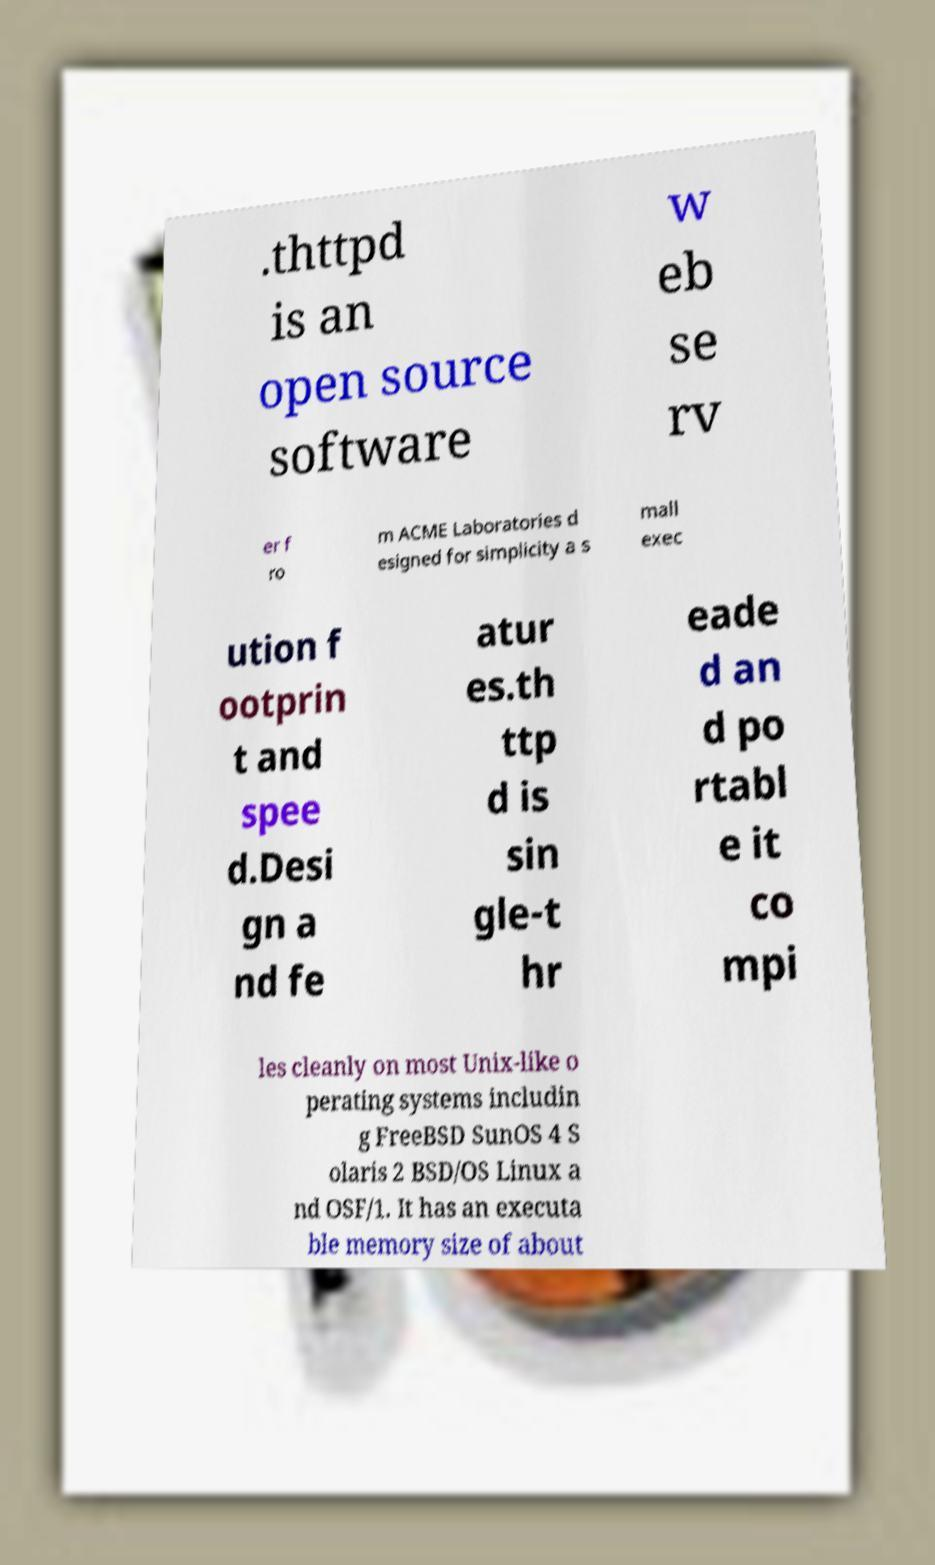Please identify and transcribe the text found in this image. .thttpd is an open source software w eb se rv er f ro m ACME Laboratories d esigned for simplicity a s mall exec ution f ootprin t and spee d.Desi gn a nd fe atur es.th ttp d is sin gle-t hr eade d an d po rtabl e it co mpi les cleanly on most Unix-like o perating systems includin g FreeBSD SunOS 4 S olaris 2 BSD/OS Linux a nd OSF/1. It has an executa ble memory size of about 